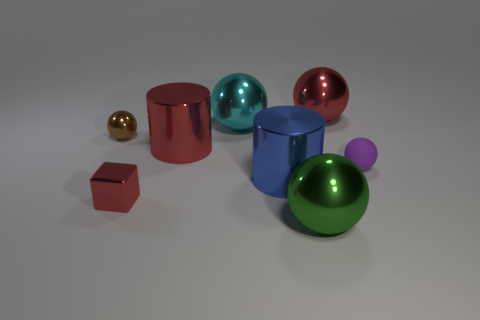Add 1 big yellow rubber blocks. How many objects exist? 9 Subtract all big red spheres. How many spheres are left? 4 Subtract 3 spheres. How many spheres are left? 2 Subtract all green spheres. How many spheres are left? 4 Subtract all cylinders. How many objects are left? 6 Subtract all big blue objects. Subtract all tiny purple rubber balls. How many objects are left? 6 Add 3 large spheres. How many large spheres are left? 6 Add 4 red cylinders. How many red cylinders exist? 5 Subtract 1 blue cylinders. How many objects are left? 7 Subtract all green cylinders. Subtract all blue balls. How many cylinders are left? 2 